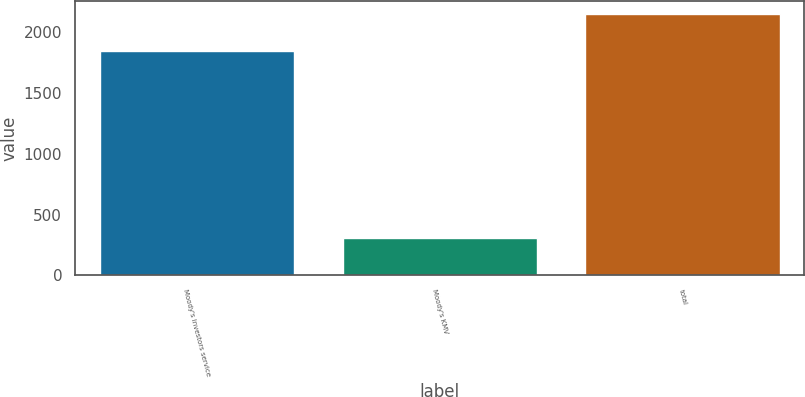Convert chart to OTSL. <chart><loc_0><loc_0><loc_500><loc_500><bar_chart><fcel>Moody's investors service<fcel>Moody's KMV<fcel>total<nl><fcel>1843<fcel>304<fcel>2147<nl></chart> 